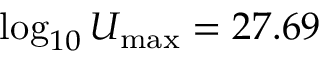Convert formula to latex. <formula><loc_0><loc_0><loc_500><loc_500>\log _ { 1 0 } U _ { \max } = 2 7 . 6 9</formula> 